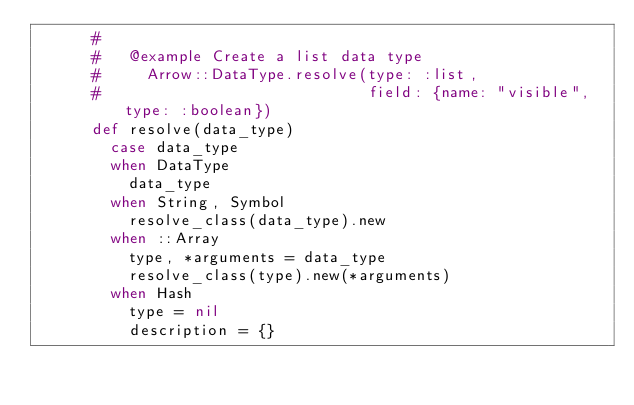Convert code to text. <code><loc_0><loc_0><loc_500><loc_500><_Ruby_>      #
      #   @example Create a list data type
      #     Arrow::DataType.resolve(type: :list,
      #                             field: {name: "visible", type: :boolean})
      def resolve(data_type)
        case data_type
        when DataType
          data_type
        when String, Symbol
          resolve_class(data_type).new
        when ::Array
          type, *arguments = data_type
          resolve_class(type).new(*arguments)
        when Hash
          type = nil
          description = {}</code> 